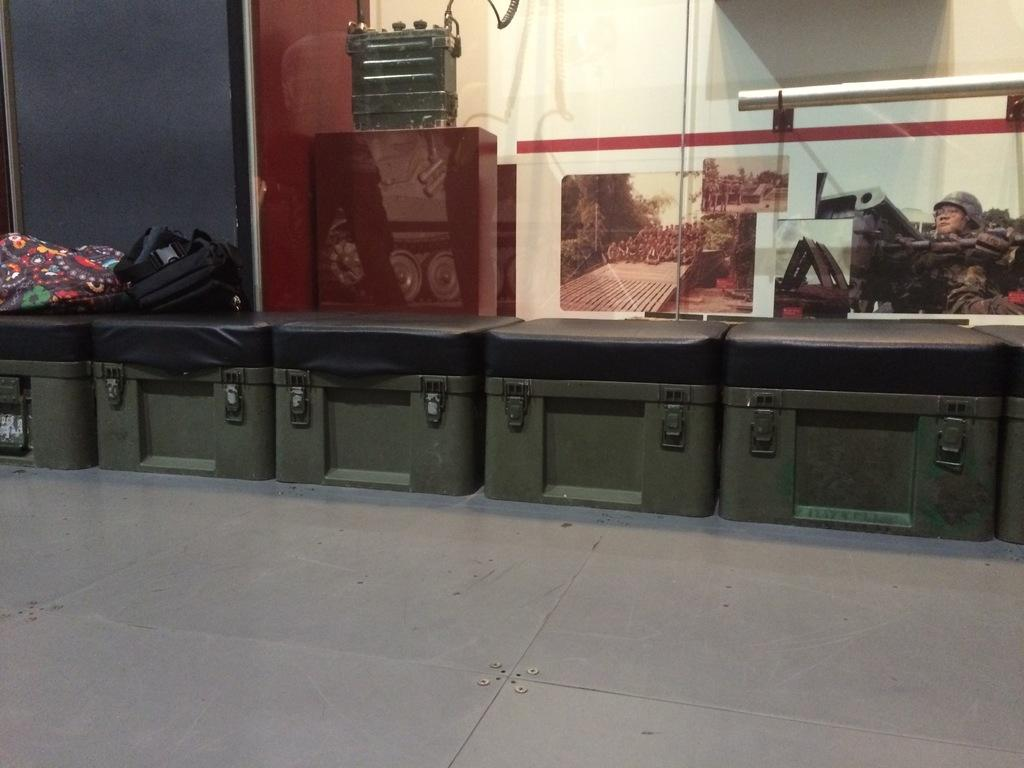What objects are near the window in the image? There are boxes near the window in the image. What is placed on one of the boxes? There are bags on one of the boxes. What can be seen inside the window? There are other boxes inside the window. What is attached to a pole in the image? There is a banner attached to a pole. What statement can be made about the smell in the image? There is no information about the smell in the image, so it cannot be determined. 